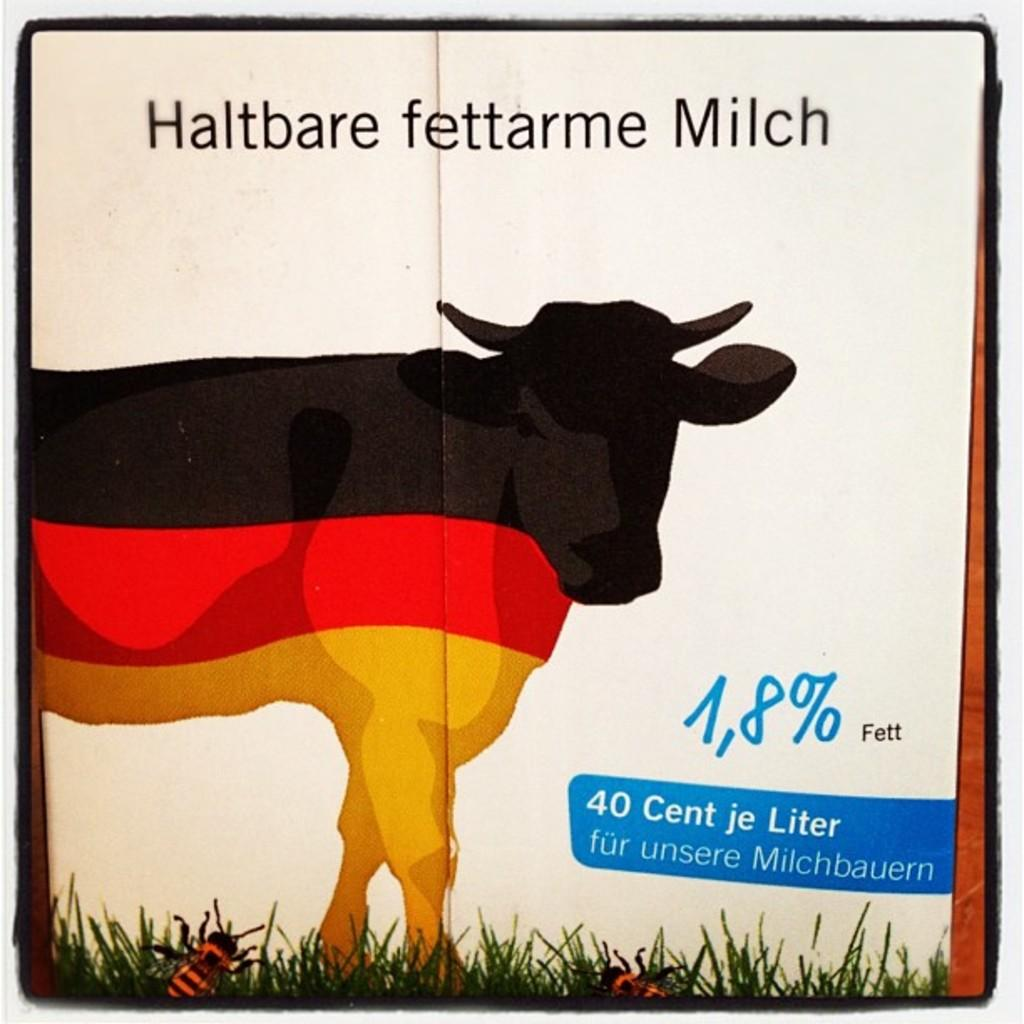What is featured on the poster in the image? The poster contains a cow, grass, and insects. Can you describe the setting depicted on the poster? The poster depicts a scene with a cow, grass, and insects. How many cars are visible in the image? There are no cars present in the image; it features a poster with a cow, grass, and insects. 